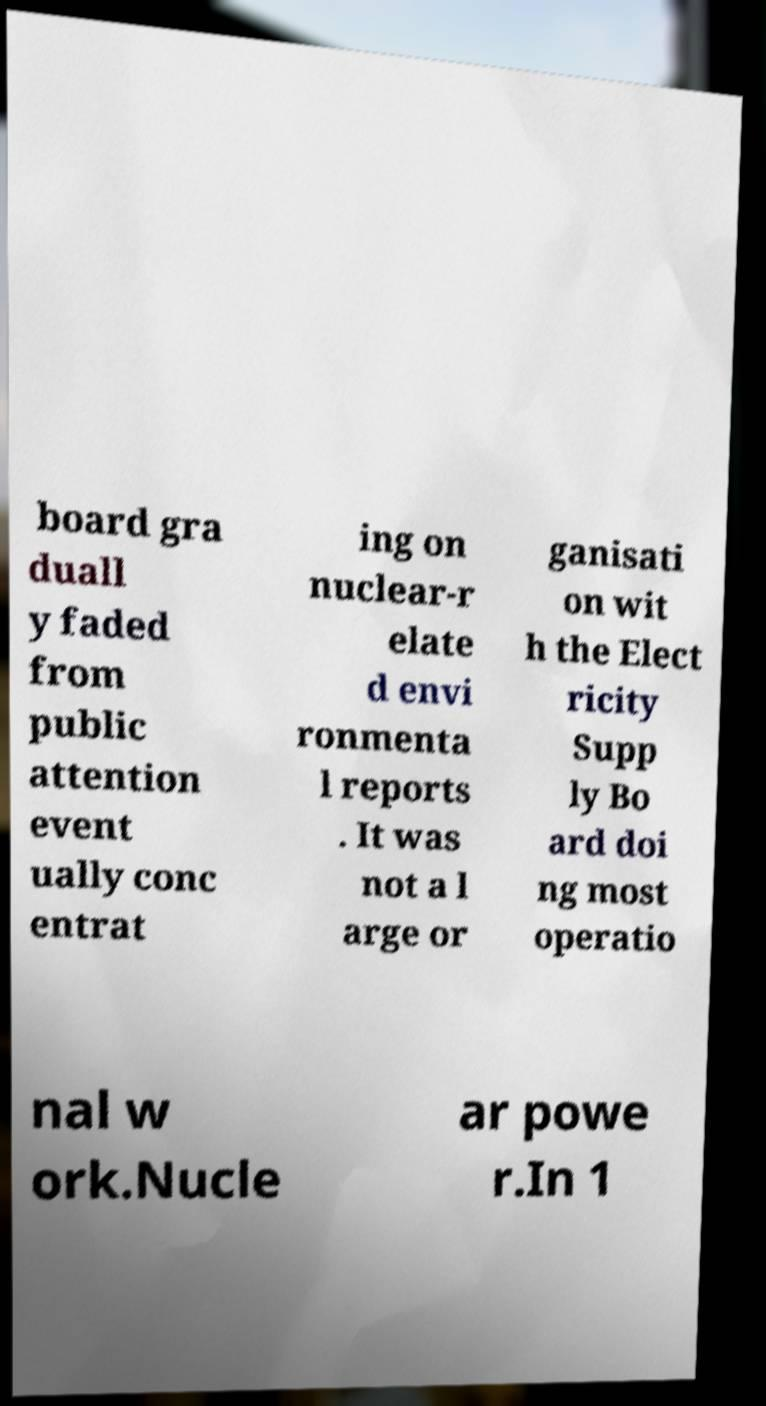I need the written content from this picture converted into text. Can you do that? board gra duall y faded from public attention event ually conc entrat ing on nuclear-r elate d envi ronmenta l reports . It was not a l arge or ganisati on wit h the Elect ricity Supp ly Bo ard doi ng most operatio nal w ork.Nucle ar powe r.In 1 